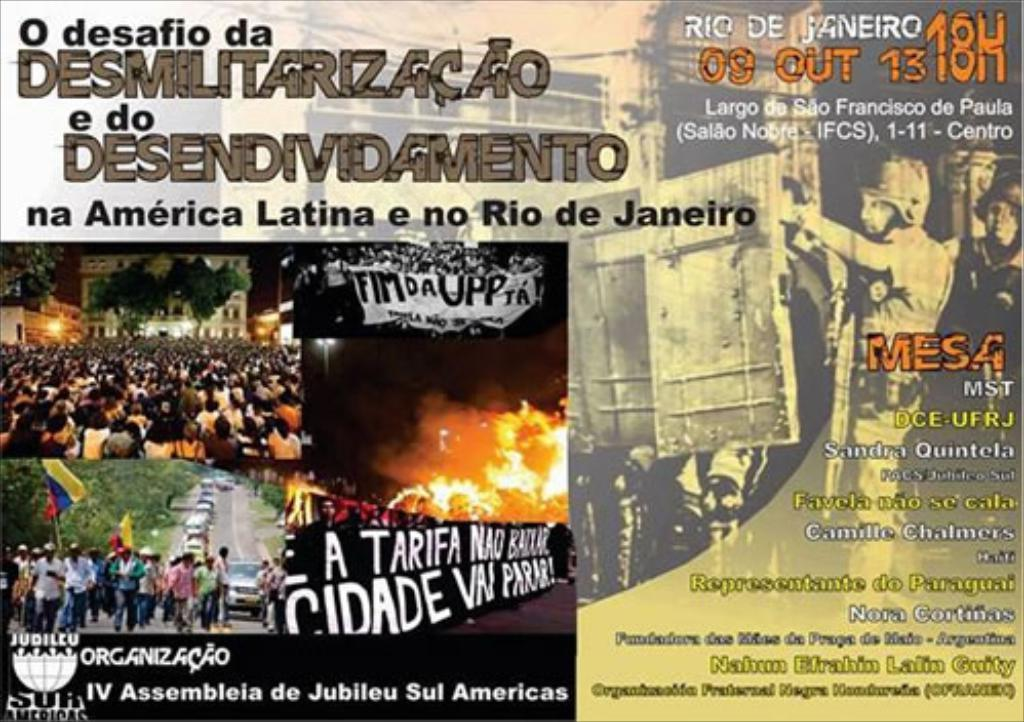Provide a one-sentence caption for the provided image. A poster with Portuguese writing on it has pictures of protesters on it. 